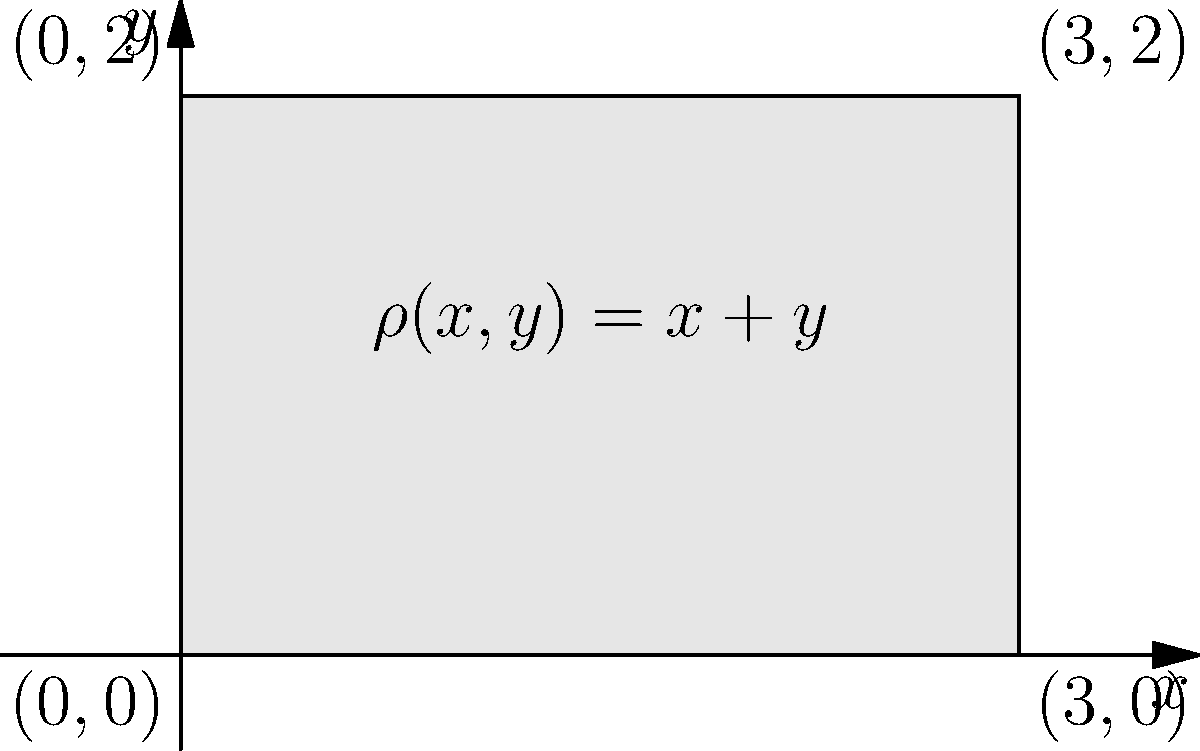A lamina occupies the rectangular region $R = \{(x,y) | 0 \leq x \leq 3, 0 \leq y \leq 2\}$ with a non-uniform density distribution given by $\rho(x,y) = x + y$. Determine the coordinates of the center of mass $(x_{cm}, y_{cm})$ of this lamina. To find the center of mass, we need to calculate the following integrals:

1) Total mass: $M = \iint_R \rho(x,y) dA$
2) First moment with respect to y-axis: $M_y = \iint_R x\rho(x,y) dA$
3) First moment with respect to x-axis: $M_x = \iint_R y\rho(x,y) dA$

Then, $x_{cm} = \frac{M_y}{M}$ and $y_{cm} = \frac{M_x}{M}$

Step 1: Calculate total mass
$$M = \int_0^2 \int_0^3 (x+y) dx dy = \int_0^2 [\frac{1}{2}x^2 + xy]_0^3 dy = \int_0^2 (\frac{9}{2} + 3y) dy = [
\frac{9}{2}y + \frac{3}{2}y^2]_0^2 = 9 + 6 = 15$$

Step 2: Calculate $M_y$
$$M_y = \int_0^2 \int_0^3 x(x+y) dx dy = \int_0^2 [\frac{1}{3}x^3 + \frac{1}{2}x^2y]_0^3 dy = \int_0^2 (9 + \frac{9}{2}y) dy = [9y + \frac{9}{4}y^2]_0^2 = 18 + 9 = 27$$

Step 3: Calculate $M_x$
$$M_x = \int_0^2 \int_0^3 y(x+y) dx dy = \int_0^2 y[\frac{1}{2}x^2 + xy]_0^3 dy = \int_0^2 y(\frac{9}{2} + 3y) dy = [\frac{9}{4}y^2 + y^3]_0^2 = 9 + 8 = 17$$

Step 4: Calculate $x_{cm}$ and $y_{cm}$
$$x_{cm} = \frac{M_y}{M} = \frac{27}{15} = \frac{9}{5} = 1.8$$
$$y_{cm} = \frac{M_x}{M} = \frac{17}{15} = \frac{17}{15} \approx 1.13$$
Answer: $(\frac{9}{5}, \frac{17}{15})$ 